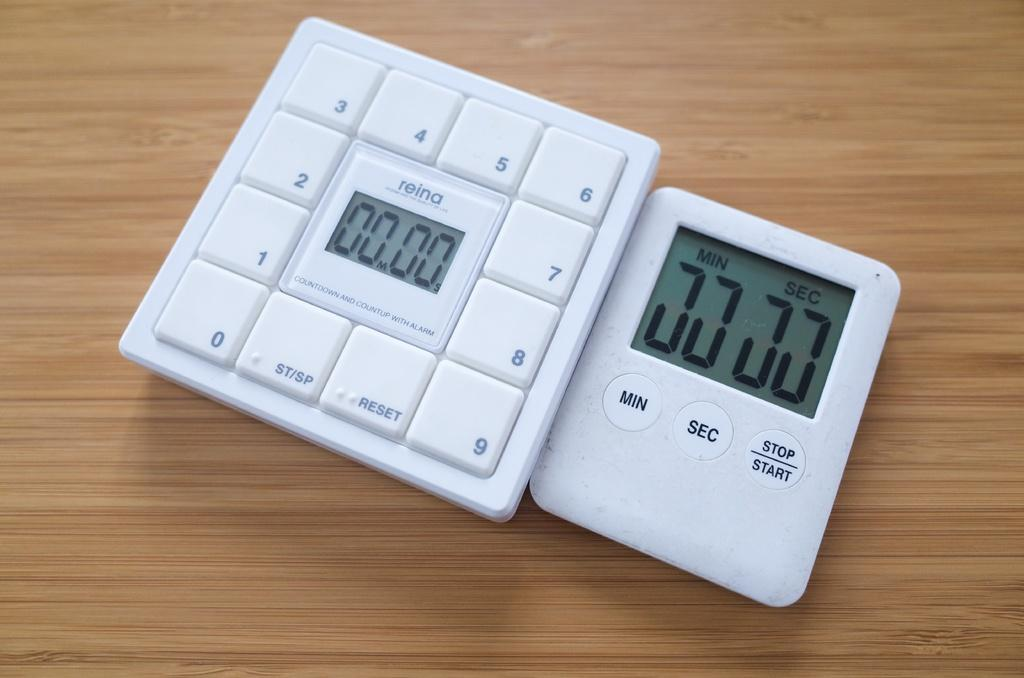Provide a one-sentence caption for the provided image. A white timer and keypad that both currently read 00.00. 